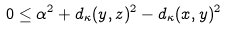<formula> <loc_0><loc_0><loc_500><loc_500>0 \leq \alpha ^ { 2 } + d _ { \kappa } ( y , z ) ^ { 2 } - d _ { \kappa } ( x , y ) ^ { 2 }</formula> 